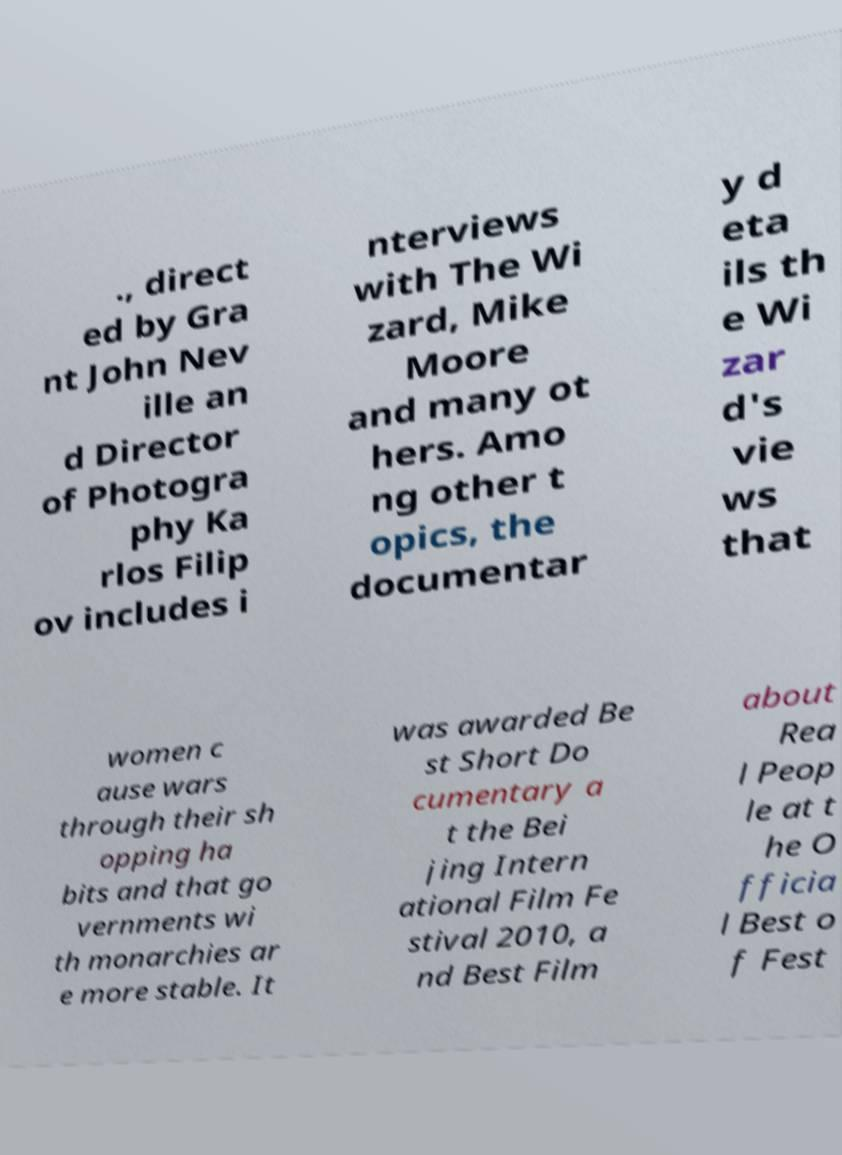I need the written content from this picture converted into text. Can you do that? ., direct ed by Gra nt John Nev ille an d Director of Photogra phy Ka rlos Filip ov includes i nterviews with The Wi zard, Mike Moore and many ot hers. Amo ng other t opics, the documentar y d eta ils th e Wi zar d's vie ws that women c ause wars through their sh opping ha bits and that go vernments wi th monarchies ar e more stable. It was awarded Be st Short Do cumentary a t the Bei jing Intern ational Film Fe stival 2010, a nd Best Film about Rea l Peop le at t he O fficia l Best o f Fest 